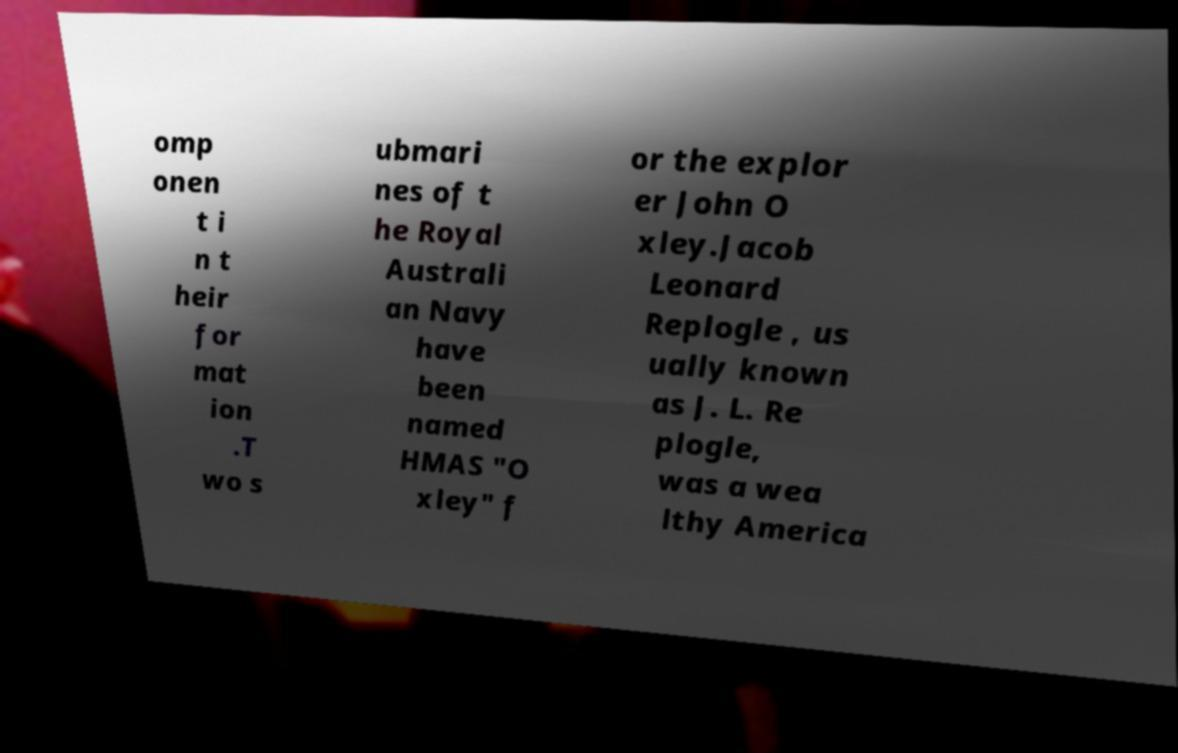What messages or text are displayed in this image? I need them in a readable, typed format. omp onen t i n t heir for mat ion .T wo s ubmari nes of t he Royal Australi an Navy have been named HMAS "O xley" f or the explor er John O xley.Jacob Leonard Replogle , us ually known as J. L. Re plogle, was a wea lthy America 